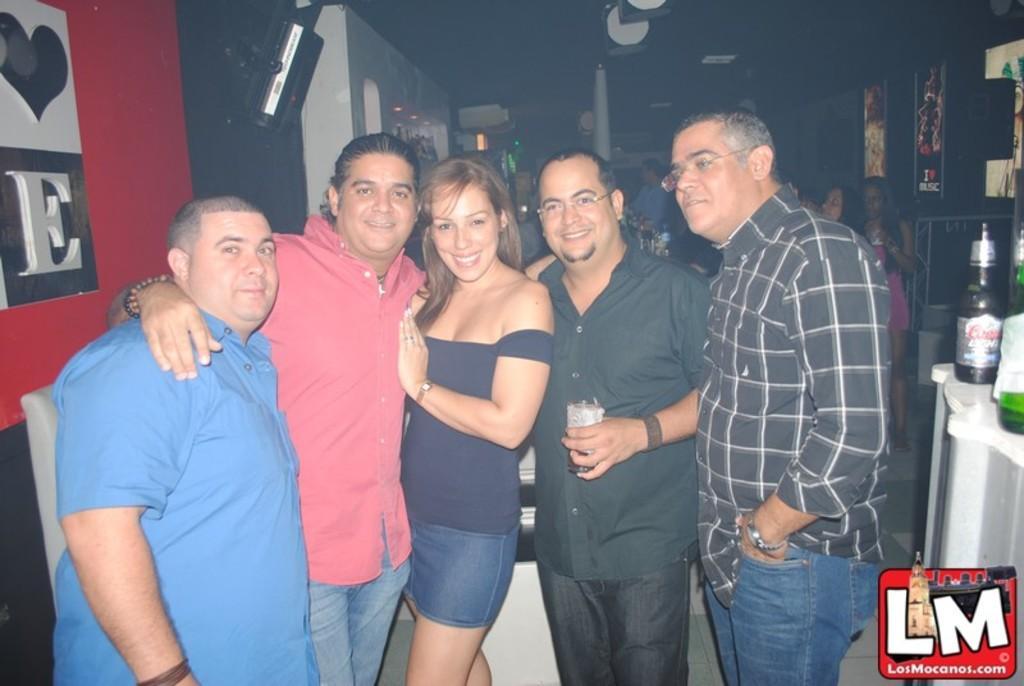In one or two sentences, can you explain what this image depicts? In this picture there are some men and women standing in the front of the camera, smiling and giving a pose. Behind there is a white color wooden paneling wall and black speaker. On the right side there are some wine bottles on the white color table. 